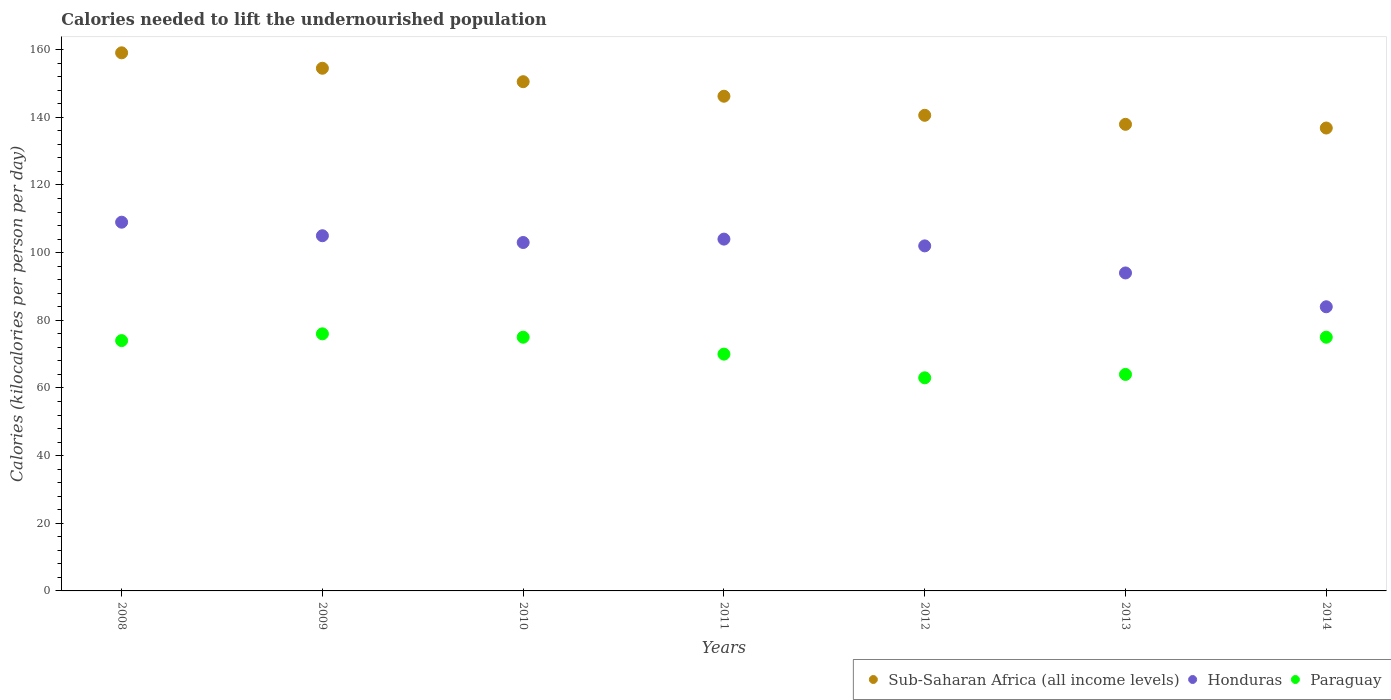How many different coloured dotlines are there?
Provide a short and direct response. 3. Is the number of dotlines equal to the number of legend labels?
Your response must be concise. Yes. What is the total calories needed to lift the undernourished population in Honduras in 2009?
Your response must be concise. 105. Across all years, what is the maximum total calories needed to lift the undernourished population in Sub-Saharan Africa (all income levels)?
Provide a succinct answer. 159.07. Across all years, what is the minimum total calories needed to lift the undernourished population in Paraguay?
Ensure brevity in your answer.  63. In which year was the total calories needed to lift the undernourished population in Paraguay maximum?
Your response must be concise. 2009. In which year was the total calories needed to lift the undernourished population in Honduras minimum?
Ensure brevity in your answer.  2014. What is the total total calories needed to lift the undernourished population in Paraguay in the graph?
Ensure brevity in your answer.  497. What is the difference between the total calories needed to lift the undernourished population in Sub-Saharan Africa (all income levels) in 2009 and that in 2010?
Give a very brief answer. 3.97. What is the difference between the total calories needed to lift the undernourished population in Paraguay in 2011 and the total calories needed to lift the undernourished population in Honduras in 2012?
Your response must be concise. -32. In the year 2013, what is the difference between the total calories needed to lift the undernourished population in Honduras and total calories needed to lift the undernourished population in Paraguay?
Provide a short and direct response. 30. What is the ratio of the total calories needed to lift the undernourished population in Paraguay in 2008 to that in 2010?
Make the answer very short. 0.99. What is the difference between the highest and the lowest total calories needed to lift the undernourished population in Sub-Saharan Africa (all income levels)?
Offer a terse response. 22.23. In how many years, is the total calories needed to lift the undernourished population in Sub-Saharan Africa (all income levels) greater than the average total calories needed to lift the undernourished population in Sub-Saharan Africa (all income levels) taken over all years?
Make the answer very short. 3. Is it the case that in every year, the sum of the total calories needed to lift the undernourished population in Honduras and total calories needed to lift the undernourished population in Paraguay  is greater than the total calories needed to lift the undernourished population in Sub-Saharan Africa (all income levels)?
Offer a terse response. Yes. Is the total calories needed to lift the undernourished population in Paraguay strictly greater than the total calories needed to lift the undernourished population in Honduras over the years?
Ensure brevity in your answer.  No. Is the total calories needed to lift the undernourished population in Honduras strictly less than the total calories needed to lift the undernourished population in Paraguay over the years?
Keep it short and to the point. No. How many years are there in the graph?
Ensure brevity in your answer.  7. What is the difference between two consecutive major ticks on the Y-axis?
Give a very brief answer. 20. Are the values on the major ticks of Y-axis written in scientific E-notation?
Your answer should be very brief. No. How many legend labels are there?
Offer a very short reply. 3. What is the title of the graph?
Ensure brevity in your answer.  Calories needed to lift the undernourished population. Does "Lebanon" appear as one of the legend labels in the graph?
Offer a terse response. No. What is the label or title of the X-axis?
Your answer should be very brief. Years. What is the label or title of the Y-axis?
Your answer should be very brief. Calories (kilocalories per person per day). What is the Calories (kilocalories per person per day) in Sub-Saharan Africa (all income levels) in 2008?
Ensure brevity in your answer.  159.07. What is the Calories (kilocalories per person per day) in Honduras in 2008?
Your response must be concise. 109. What is the Calories (kilocalories per person per day) of Sub-Saharan Africa (all income levels) in 2009?
Provide a short and direct response. 154.51. What is the Calories (kilocalories per person per day) of Honduras in 2009?
Offer a very short reply. 105. What is the Calories (kilocalories per person per day) in Paraguay in 2009?
Give a very brief answer. 76. What is the Calories (kilocalories per person per day) in Sub-Saharan Africa (all income levels) in 2010?
Provide a short and direct response. 150.54. What is the Calories (kilocalories per person per day) of Honduras in 2010?
Ensure brevity in your answer.  103. What is the Calories (kilocalories per person per day) of Paraguay in 2010?
Make the answer very short. 75. What is the Calories (kilocalories per person per day) in Sub-Saharan Africa (all income levels) in 2011?
Your answer should be very brief. 146.24. What is the Calories (kilocalories per person per day) of Honduras in 2011?
Offer a very short reply. 104. What is the Calories (kilocalories per person per day) of Sub-Saharan Africa (all income levels) in 2012?
Provide a succinct answer. 140.6. What is the Calories (kilocalories per person per day) of Honduras in 2012?
Your answer should be very brief. 102. What is the Calories (kilocalories per person per day) of Paraguay in 2012?
Your answer should be compact. 63. What is the Calories (kilocalories per person per day) in Sub-Saharan Africa (all income levels) in 2013?
Your response must be concise. 137.94. What is the Calories (kilocalories per person per day) in Honduras in 2013?
Make the answer very short. 94. What is the Calories (kilocalories per person per day) in Sub-Saharan Africa (all income levels) in 2014?
Make the answer very short. 136.84. Across all years, what is the maximum Calories (kilocalories per person per day) in Sub-Saharan Africa (all income levels)?
Make the answer very short. 159.07. Across all years, what is the maximum Calories (kilocalories per person per day) of Honduras?
Your answer should be very brief. 109. Across all years, what is the maximum Calories (kilocalories per person per day) of Paraguay?
Offer a very short reply. 76. Across all years, what is the minimum Calories (kilocalories per person per day) of Sub-Saharan Africa (all income levels)?
Your answer should be very brief. 136.84. What is the total Calories (kilocalories per person per day) in Sub-Saharan Africa (all income levels) in the graph?
Your response must be concise. 1025.74. What is the total Calories (kilocalories per person per day) of Honduras in the graph?
Ensure brevity in your answer.  701. What is the total Calories (kilocalories per person per day) in Paraguay in the graph?
Keep it short and to the point. 497. What is the difference between the Calories (kilocalories per person per day) in Sub-Saharan Africa (all income levels) in 2008 and that in 2009?
Keep it short and to the point. 4.56. What is the difference between the Calories (kilocalories per person per day) in Honduras in 2008 and that in 2009?
Offer a terse response. 4. What is the difference between the Calories (kilocalories per person per day) of Paraguay in 2008 and that in 2009?
Give a very brief answer. -2. What is the difference between the Calories (kilocalories per person per day) in Sub-Saharan Africa (all income levels) in 2008 and that in 2010?
Keep it short and to the point. 8.54. What is the difference between the Calories (kilocalories per person per day) of Honduras in 2008 and that in 2010?
Your answer should be very brief. 6. What is the difference between the Calories (kilocalories per person per day) of Paraguay in 2008 and that in 2010?
Keep it short and to the point. -1. What is the difference between the Calories (kilocalories per person per day) of Sub-Saharan Africa (all income levels) in 2008 and that in 2011?
Make the answer very short. 12.83. What is the difference between the Calories (kilocalories per person per day) in Honduras in 2008 and that in 2011?
Your response must be concise. 5. What is the difference between the Calories (kilocalories per person per day) of Paraguay in 2008 and that in 2011?
Make the answer very short. 4. What is the difference between the Calories (kilocalories per person per day) of Sub-Saharan Africa (all income levels) in 2008 and that in 2012?
Give a very brief answer. 18.47. What is the difference between the Calories (kilocalories per person per day) of Honduras in 2008 and that in 2012?
Provide a short and direct response. 7. What is the difference between the Calories (kilocalories per person per day) of Paraguay in 2008 and that in 2012?
Make the answer very short. 11. What is the difference between the Calories (kilocalories per person per day) of Sub-Saharan Africa (all income levels) in 2008 and that in 2013?
Offer a very short reply. 21.14. What is the difference between the Calories (kilocalories per person per day) in Honduras in 2008 and that in 2013?
Offer a terse response. 15. What is the difference between the Calories (kilocalories per person per day) of Paraguay in 2008 and that in 2013?
Your answer should be compact. 10. What is the difference between the Calories (kilocalories per person per day) of Sub-Saharan Africa (all income levels) in 2008 and that in 2014?
Make the answer very short. 22.23. What is the difference between the Calories (kilocalories per person per day) in Honduras in 2008 and that in 2014?
Offer a very short reply. 25. What is the difference between the Calories (kilocalories per person per day) in Sub-Saharan Africa (all income levels) in 2009 and that in 2010?
Ensure brevity in your answer.  3.97. What is the difference between the Calories (kilocalories per person per day) of Paraguay in 2009 and that in 2010?
Ensure brevity in your answer.  1. What is the difference between the Calories (kilocalories per person per day) of Sub-Saharan Africa (all income levels) in 2009 and that in 2011?
Offer a terse response. 8.27. What is the difference between the Calories (kilocalories per person per day) in Sub-Saharan Africa (all income levels) in 2009 and that in 2012?
Ensure brevity in your answer.  13.91. What is the difference between the Calories (kilocalories per person per day) of Paraguay in 2009 and that in 2012?
Provide a succinct answer. 13. What is the difference between the Calories (kilocalories per person per day) in Sub-Saharan Africa (all income levels) in 2009 and that in 2013?
Make the answer very short. 16.58. What is the difference between the Calories (kilocalories per person per day) of Honduras in 2009 and that in 2013?
Your answer should be compact. 11. What is the difference between the Calories (kilocalories per person per day) of Paraguay in 2009 and that in 2013?
Your response must be concise. 12. What is the difference between the Calories (kilocalories per person per day) in Sub-Saharan Africa (all income levels) in 2009 and that in 2014?
Ensure brevity in your answer.  17.67. What is the difference between the Calories (kilocalories per person per day) of Sub-Saharan Africa (all income levels) in 2010 and that in 2011?
Give a very brief answer. 4.3. What is the difference between the Calories (kilocalories per person per day) of Sub-Saharan Africa (all income levels) in 2010 and that in 2012?
Your answer should be very brief. 9.93. What is the difference between the Calories (kilocalories per person per day) in Honduras in 2010 and that in 2012?
Make the answer very short. 1. What is the difference between the Calories (kilocalories per person per day) of Sub-Saharan Africa (all income levels) in 2010 and that in 2013?
Provide a succinct answer. 12.6. What is the difference between the Calories (kilocalories per person per day) in Paraguay in 2010 and that in 2013?
Make the answer very short. 11. What is the difference between the Calories (kilocalories per person per day) of Sub-Saharan Africa (all income levels) in 2010 and that in 2014?
Your answer should be compact. 13.7. What is the difference between the Calories (kilocalories per person per day) of Honduras in 2010 and that in 2014?
Offer a terse response. 19. What is the difference between the Calories (kilocalories per person per day) of Paraguay in 2010 and that in 2014?
Your answer should be very brief. 0. What is the difference between the Calories (kilocalories per person per day) of Sub-Saharan Africa (all income levels) in 2011 and that in 2012?
Offer a very short reply. 5.64. What is the difference between the Calories (kilocalories per person per day) in Sub-Saharan Africa (all income levels) in 2011 and that in 2013?
Give a very brief answer. 8.31. What is the difference between the Calories (kilocalories per person per day) in Honduras in 2011 and that in 2013?
Your response must be concise. 10. What is the difference between the Calories (kilocalories per person per day) in Sub-Saharan Africa (all income levels) in 2011 and that in 2014?
Offer a terse response. 9.4. What is the difference between the Calories (kilocalories per person per day) of Sub-Saharan Africa (all income levels) in 2012 and that in 2013?
Offer a terse response. 2.67. What is the difference between the Calories (kilocalories per person per day) of Honduras in 2012 and that in 2013?
Give a very brief answer. 8. What is the difference between the Calories (kilocalories per person per day) of Paraguay in 2012 and that in 2013?
Offer a terse response. -1. What is the difference between the Calories (kilocalories per person per day) of Sub-Saharan Africa (all income levels) in 2012 and that in 2014?
Your answer should be very brief. 3.76. What is the difference between the Calories (kilocalories per person per day) of Sub-Saharan Africa (all income levels) in 2013 and that in 2014?
Your response must be concise. 1.1. What is the difference between the Calories (kilocalories per person per day) in Paraguay in 2013 and that in 2014?
Provide a succinct answer. -11. What is the difference between the Calories (kilocalories per person per day) in Sub-Saharan Africa (all income levels) in 2008 and the Calories (kilocalories per person per day) in Honduras in 2009?
Offer a very short reply. 54.07. What is the difference between the Calories (kilocalories per person per day) of Sub-Saharan Africa (all income levels) in 2008 and the Calories (kilocalories per person per day) of Paraguay in 2009?
Your answer should be very brief. 83.07. What is the difference between the Calories (kilocalories per person per day) of Honduras in 2008 and the Calories (kilocalories per person per day) of Paraguay in 2009?
Provide a succinct answer. 33. What is the difference between the Calories (kilocalories per person per day) in Sub-Saharan Africa (all income levels) in 2008 and the Calories (kilocalories per person per day) in Honduras in 2010?
Keep it short and to the point. 56.07. What is the difference between the Calories (kilocalories per person per day) of Sub-Saharan Africa (all income levels) in 2008 and the Calories (kilocalories per person per day) of Paraguay in 2010?
Provide a succinct answer. 84.07. What is the difference between the Calories (kilocalories per person per day) in Honduras in 2008 and the Calories (kilocalories per person per day) in Paraguay in 2010?
Offer a very short reply. 34. What is the difference between the Calories (kilocalories per person per day) in Sub-Saharan Africa (all income levels) in 2008 and the Calories (kilocalories per person per day) in Honduras in 2011?
Give a very brief answer. 55.07. What is the difference between the Calories (kilocalories per person per day) in Sub-Saharan Africa (all income levels) in 2008 and the Calories (kilocalories per person per day) in Paraguay in 2011?
Offer a very short reply. 89.07. What is the difference between the Calories (kilocalories per person per day) of Sub-Saharan Africa (all income levels) in 2008 and the Calories (kilocalories per person per day) of Honduras in 2012?
Offer a terse response. 57.07. What is the difference between the Calories (kilocalories per person per day) of Sub-Saharan Africa (all income levels) in 2008 and the Calories (kilocalories per person per day) of Paraguay in 2012?
Keep it short and to the point. 96.07. What is the difference between the Calories (kilocalories per person per day) in Honduras in 2008 and the Calories (kilocalories per person per day) in Paraguay in 2012?
Your answer should be compact. 46. What is the difference between the Calories (kilocalories per person per day) of Sub-Saharan Africa (all income levels) in 2008 and the Calories (kilocalories per person per day) of Honduras in 2013?
Keep it short and to the point. 65.07. What is the difference between the Calories (kilocalories per person per day) in Sub-Saharan Africa (all income levels) in 2008 and the Calories (kilocalories per person per day) in Paraguay in 2013?
Provide a short and direct response. 95.07. What is the difference between the Calories (kilocalories per person per day) in Honduras in 2008 and the Calories (kilocalories per person per day) in Paraguay in 2013?
Your answer should be compact. 45. What is the difference between the Calories (kilocalories per person per day) in Sub-Saharan Africa (all income levels) in 2008 and the Calories (kilocalories per person per day) in Honduras in 2014?
Keep it short and to the point. 75.07. What is the difference between the Calories (kilocalories per person per day) in Sub-Saharan Africa (all income levels) in 2008 and the Calories (kilocalories per person per day) in Paraguay in 2014?
Provide a short and direct response. 84.07. What is the difference between the Calories (kilocalories per person per day) in Sub-Saharan Africa (all income levels) in 2009 and the Calories (kilocalories per person per day) in Honduras in 2010?
Give a very brief answer. 51.51. What is the difference between the Calories (kilocalories per person per day) of Sub-Saharan Africa (all income levels) in 2009 and the Calories (kilocalories per person per day) of Paraguay in 2010?
Give a very brief answer. 79.51. What is the difference between the Calories (kilocalories per person per day) of Honduras in 2009 and the Calories (kilocalories per person per day) of Paraguay in 2010?
Provide a succinct answer. 30. What is the difference between the Calories (kilocalories per person per day) in Sub-Saharan Africa (all income levels) in 2009 and the Calories (kilocalories per person per day) in Honduras in 2011?
Your answer should be compact. 50.51. What is the difference between the Calories (kilocalories per person per day) in Sub-Saharan Africa (all income levels) in 2009 and the Calories (kilocalories per person per day) in Paraguay in 2011?
Keep it short and to the point. 84.51. What is the difference between the Calories (kilocalories per person per day) in Honduras in 2009 and the Calories (kilocalories per person per day) in Paraguay in 2011?
Your answer should be compact. 35. What is the difference between the Calories (kilocalories per person per day) in Sub-Saharan Africa (all income levels) in 2009 and the Calories (kilocalories per person per day) in Honduras in 2012?
Offer a terse response. 52.51. What is the difference between the Calories (kilocalories per person per day) in Sub-Saharan Africa (all income levels) in 2009 and the Calories (kilocalories per person per day) in Paraguay in 2012?
Provide a succinct answer. 91.51. What is the difference between the Calories (kilocalories per person per day) in Sub-Saharan Africa (all income levels) in 2009 and the Calories (kilocalories per person per day) in Honduras in 2013?
Your answer should be compact. 60.51. What is the difference between the Calories (kilocalories per person per day) of Sub-Saharan Africa (all income levels) in 2009 and the Calories (kilocalories per person per day) of Paraguay in 2013?
Provide a succinct answer. 90.51. What is the difference between the Calories (kilocalories per person per day) in Sub-Saharan Africa (all income levels) in 2009 and the Calories (kilocalories per person per day) in Honduras in 2014?
Provide a short and direct response. 70.51. What is the difference between the Calories (kilocalories per person per day) of Sub-Saharan Africa (all income levels) in 2009 and the Calories (kilocalories per person per day) of Paraguay in 2014?
Your response must be concise. 79.51. What is the difference between the Calories (kilocalories per person per day) in Honduras in 2009 and the Calories (kilocalories per person per day) in Paraguay in 2014?
Provide a short and direct response. 30. What is the difference between the Calories (kilocalories per person per day) of Sub-Saharan Africa (all income levels) in 2010 and the Calories (kilocalories per person per day) of Honduras in 2011?
Offer a very short reply. 46.54. What is the difference between the Calories (kilocalories per person per day) in Sub-Saharan Africa (all income levels) in 2010 and the Calories (kilocalories per person per day) in Paraguay in 2011?
Offer a very short reply. 80.54. What is the difference between the Calories (kilocalories per person per day) in Sub-Saharan Africa (all income levels) in 2010 and the Calories (kilocalories per person per day) in Honduras in 2012?
Keep it short and to the point. 48.54. What is the difference between the Calories (kilocalories per person per day) in Sub-Saharan Africa (all income levels) in 2010 and the Calories (kilocalories per person per day) in Paraguay in 2012?
Keep it short and to the point. 87.54. What is the difference between the Calories (kilocalories per person per day) in Sub-Saharan Africa (all income levels) in 2010 and the Calories (kilocalories per person per day) in Honduras in 2013?
Keep it short and to the point. 56.54. What is the difference between the Calories (kilocalories per person per day) of Sub-Saharan Africa (all income levels) in 2010 and the Calories (kilocalories per person per day) of Paraguay in 2013?
Offer a terse response. 86.54. What is the difference between the Calories (kilocalories per person per day) in Sub-Saharan Africa (all income levels) in 2010 and the Calories (kilocalories per person per day) in Honduras in 2014?
Offer a terse response. 66.54. What is the difference between the Calories (kilocalories per person per day) in Sub-Saharan Africa (all income levels) in 2010 and the Calories (kilocalories per person per day) in Paraguay in 2014?
Make the answer very short. 75.54. What is the difference between the Calories (kilocalories per person per day) in Honduras in 2010 and the Calories (kilocalories per person per day) in Paraguay in 2014?
Offer a terse response. 28. What is the difference between the Calories (kilocalories per person per day) in Sub-Saharan Africa (all income levels) in 2011 and the Calories (kilocalories per person per day) in Honduras in 2012?
Ensure brevity in your answer.  44.24. What is the difference between the Calories (kilocalories per person per day) in Sub-Saharan Africa (all income levels) in 2011 and the Calories (kilocalories per person per day) in Paraguay in 2012?
Give a very brief answer. 83.24. What is the difference between the Calories (kilocalories per person per day) in Sub-Saharan Africa (all income levels) in 2011 and the Calories (kilocalories per person per day) in Honduras in 2013?
Your answer should be very brief. 52.24. What is the difference between the Calories (kilocalories per person per day) in Sub-Saharan Africa (all income levels) in 2011 and the Calories (kilocalories per person per day) in Paraguay in 2013?
Offer a terse response. 82.24. What is the difference between the Calories (kilocalories per person per day) of Sub-Saharan Africa (all income levels) in 2011 and the Calories (kilocalories per person per day) of Honduras in 2014?
Give a very brief answer. 62.24. What is the difference between the Calories (kilocalories per person per day) of Sub-Saharan Africa (all income levels) in 2011 and the Calories (kilocalories per person per day) of Paraguay in 2014?
Give a very brief answer. 71.24. What is the difference between the Calories (kilocalories per person per day) of Honduras in 2011 and the Calories (kilocalories per person per day) of Paraguay in 2014?
Make the answer very short. 29. What is the difference between the Calories (kilocalories per person per day) in Sub-Saharan Africa (all income levels) in 2012 and the Calories (kilocalories per person per day) in Honduras in 2013?
Ensure brevity in your answer.  46.6. What is the difference between the Calories (kilocalories per person per day) of Sub-Saharan Africa (all income levels) in 2012 and the Calories (kilocalories per person per day) of Paraguay in 2013?
Provide a short and direct response. 76.6. What is the difference between the Calories (kilocalories per person per day) in Sub-Saharan Africa (all income levels) in 2012 and the Calories (kilocalories per person per day) in Honduras in 2014?
Ensure brevity in your answer.  56.6. What is the difference between the Calories (kilocalories per person per day) in Sub-Saharan Africa (all income levels) in 2012 and the Calories (kilocalories per person per day) in Paraguay in 2014?
Make the answer very short. 65.6. What is the difference between the Calories (kilocalories per person per day) of Honduras in 2012 and the Calories (kilocalories per person per day) of Paraguay in 2014?
Provide a short and direct response. 27. What is the difference between the Calories (kilocalories per person per day) in Sub-Saharan Africa (all income levels) in 2013 and the Calories (kilocalories per person per day) in Honduras in 2014?
Your answer should be very brief. 53.94. What is the difference between the Calories (kilocalories per person per day) of Sub-Saharan Africa (all income levels) in 2013 and the Calories (kilocalories per person per day) of Paraguay in 2014?
Provide a succinct answer. 62.94. What is the difference between the Calories (kilocalories per person per day) in Honduras in 2013 and the Calories (kilocalories per person per day) in Paraguay in 2014?
Keep it short and to the point. 19. What is the average Calories (kilocalories per person per day) in Sub-Saharan Africa (all income levels) per year?
Your response must be concise. 146.53. What is the average Calories (kilocalories per person per day) in Honduras per year?
Ensure brevity in your answer.  100.14. In the year 2008, what is the difference between the Calories (kilocalories per person per day) of Sub-Saharan Africa (all income levels) and Calories (kilocalories per person per day) of Honduras?
Your answer should be compact. 50.07. In the year 2008, what is the difference between the Calories (kilocalories per person per day) in Sub-Saharan Africa (all income levels) and Calories (kilocalories per person per day) in Paraguay?
Your answer should be very brief. 85.07. In the year 2008, what is the difference between the Calories (kilocalories per person per day) of Honduras and Calories (kilocalories per person per day) of Paraguay?
Your answer should be compact. 35. In the year 2009, what is the difference between the Calories (kilocalories per person per day) in Sub-Saharan Africa (all income levels) and Calories (kilocalories per person per day) in Honduras?
Your answer should be very brief. 49.51. In the year 2009, what is the difference between the Calories (kilocalories per person per day) in Sub-Saharan Africa (all income levels) and Calories (kilocalories per person per day) in Paraguay?
Provide a short and direct response. 78.51. In the year 2009, what is the difference between the Calories (kilocalories per person per day) of Honduras and Calories (kilocalories per person per day) of Paraguay?
Your response must be concise. 29. In the year 2010, what is the difference between the Calories (kilocalories per person per day) in Sub-Saharan Africa (all income levels) and Calories (kilocalories per person per day) in Honduras?
Your answer should be very brief. 47.54. In the year 2010, what is the difference between the Calories (kilocalories per person per day) in Sub-Saharan Africa (all income levels) and Calories (kilocalories per person per day) in Paraguay?
Provide a short and direct response. 75.54. In the year 2011, what is the difference between the Calories (kilocalories per person per day) in Sub-Saharan Africa (all income levels) and Calories (kilocalories per person per day) in Honduras?
Keep it short and to the point. 42.24. In the year 2011, what is the difference between the Calories (kilocalories per person per day) in Sub-Saharan Africa (all income levels) and Calories (kilocalories per person per day) in Paraguay?
Give a very brief answer. 76.24. In the year 2011, what is the difference between the Calories (kilocalories per person per day) of Honduras and Calories (kilocalories per person per day) of Paraguay?
Give a very brief answer. 34. In the year 2012, what is the difference between the Calories (kilocalories per person per day) of Sub-Saharan Africa (all income levels) and Calories (kilocalories per person per day) of Honduras?
Offer a very short reply. 38.6. In the year 2012, what is the difference between the Calories (kilocalories per person per day) in Sub-Saharan Africa (all income levels) and Calories (kilocalories per person per day) in Paraguay?
Provide a succinct answer. 77.6. In the year 2013, what is the difference between the Calories (kilocalories per person per day) in Sub-Saharan Africa (all income levels) and Calories (kilocalories per person per day) in Honduras?
Ensure brevity in your answer.  43.94. In the year 2013, what is the difference between the Calories (kilocalories per person per day) of Sub-Saharan Africa (all income levels) and Calories (kilocalories per person per day) of Paraguay?
Keep it short and to the point. 73.94. In the year 2013, what is the difference between the Calories (kilocalories per person per day) in Honduras and Calories (kilocalories per person per day) in Paraguay?
Offer a very short reply. 30. In the year 2014, what is the difference between the Calories (kilocalories per person per day) in Sub-Saharan Africa (all income levels) and Calories (kilocalories per person per day) in Honduras?
Provide a short and direct response. 52.84. In the year 2014, what is the difference between the Calories (kilocalories per person per day) of Sub-Saharan Africa (all income levels) and Calories (kilocalories per person per day) of Paraguay?
Ensure brevity in your answer.  61.84. In the year 2014, what is the difference between the Calories (kilocalories per person per day) of Honduras and Calories (kilocalories per person per day) of Paraguay?
Provide a succinct answer. 9. What is the ratio of the Calories (kilocalories per person per day) of Sub-Saharan Africa (all income levels) in 2008 to that in 2009?
Provide a succinct answer. 1.03. What is the ratio of the Calories (kilocalories per person per day) in Honduras in 2008 to that in 2009?
Offer a very short reply. 1.04. What is the ratio of the Calories (kilocalories per person per day) of Paraguay in 2008 to that in 2009?
Keep it short and to the point. 0.97. What is the ratio of the Calories (kilocalories per person per day) in Sub-Saharan Africa (all income levels) in 2008 to that in 2010?
Give a very brief answer. 1.06. What is the ratio of the Calories (kilocalories per person per day) in Honduras in 2008 to that in 2010?
Ensure brevity in your answer.  1.06. What is the ratio of the Calories (kilocalories per person per day) of Paraguay in 2008 to that in 2010?
Provide a short and direct response. 0.99. What is the ratio of the Calories (kilocalories per person per day) in Sub-Saharan Africa (all income levels) in 2008 to that in 2011?
Provide a succinct answer. 1.09. What is the ratio of the Calories (kilocalories per person per day) of Honduras in 2008 to that in 2011?
Your response must be concise. 1.05. What is the ratio of the Calories (kilocalories per person per day) of Paraguay in 2008 to that in 2011?
Your answer should be compact. 1.06. What is the ratio of the Calories (kilocalories per person per day) of Sub-Saharan Africa (all income levels) in 2008 to that in 2012?
Provide a succinct answer. 1.13. What is the ratio of the Calories (kilocalories per person per day) in Honduras in 2008 to that in 2012?
Give a very brief answer. 1.07. What is the ratio of the Calories (kilocalories per person per day) of Paraguay in 2008 to that in 2012?
Give a very brief answer. 1.17. What is the ratio of the Calories (kilocalories per person per day) of Sub-Saharan Africa (all income levels) in 2008 to that in 2013?
Your response must be concise. 1.15. What is the ratio of the Calories (kilocalories per person per day) in Honduras in 2008 to that in 2013?
Ensure brevity in your answer.  1.16. What is the ratio of the Calories (kilocalories per person per day) in Paraguay in 2008 to that in 2013?
Your answer should be compact. 1.16. What is the ratio of the Calories (kilocalories per person per day) in Sub-Saharan Africa (all income levels) in 2008 to that in 2014?
Your answer should be very brief. 1.16. What is the ratio of the Calories (kilocalories per person per day) of Honduras in 2008 to that in 2014?
Your response must be concise. 1.3. What is the ratio of the Calories (kilocalories per person per day) of Paraguay in 2008 to that in 2014?
Provide a succinct answer. 0.99. What is the ratio of the Calories (kilocalories per person per day) in Sub-Saharan Africa (all income levels) in 2009 to that in 2010?
Provide a short and direct response. 1.03. What is the ratio of the Calories (kilocalories per person per day) of Honduras in 2009 to that in 2010?
Your answer should be compact. 1.02. What is the ratio of the Calories (kilocalories per person per day) of Paraguay in 2009 to that in 2010?
Offer a terse response. 1.01. What is the ratio of the Calories (kilocalories per person per day) in Sub-Saharan Africa (all income levels) in 2009 to that in 2011?
Make the answer very short. 1.06. What is the ratio of the Calories (kilocalories per person per day) in Honduras in 2009 to that in 2011?
Provide a succinct answer. 1.01. What is the ratio of the Calories (kilocalories per person per day) in Paraguay in 2009 to that in 2011?
Ensure brevity in your answer.  1.09. What is the ratio of the Calories (kilocalories per person per day) in Sub-Saharan Africa (all income levels) in 2009 to that in 2012?
Ensure brevity in your answer.  1.1. What is the ratio of the Calories (kilocalories per person per day) of Honduras in 2009 to that in 2012?
Offer a very short reply. 1.03. What is the ratio of the Calories (kilocalories per person per day) of Paraguay in 2009 to that in 2012?
Offer a very short reply. 1.21. What is the ratio of the Calories (kilocalories per person per day) of Sub-Saharan Africa (all income levels) in 2009 to that in 2013?
Offer a terse response. 1.12. What is the ratio of the Calories (kilocalories per person per day) in Honduras in 2009 to that in 2013?
Keep it short and to the point. 1.12. What is the ratio of the Calories (kilocalories per person per day) in Paraguay in 2009 to that in 2013?
Offer a very short reply. 1.19. What is the ratio of the Calories (kilocalories per person per day) of Sub-Saharan Africa (all income levels) in 2009 to that in 2014?
Provide a succinct answer. 1.13. What is the ratio of the Calories (kilocalories per person per day) of Honduras in 2009 to that in 2014?
Your response must be concise. 1.25. What is the ratio of the Calories (kilocalories per person per day) in Paraguay in 2009 to that in 2014?
Provide a short and direct response. 1.01. What is the ratio of the Calories (kilocalories per person per day) of Sub-Saharan Africa (all income levels) in 2010 to that in 2011?
Provide a succinct answer. 1.03. What is the ratio of the Calories (kilocalories per person per day) in Paraguay in 2010 to that in 2011?
Your response must be concise. 1.07. What is the ratio of the Calories (kilocalories per person per day) in Sub-Saharan Africa (all income levels) in 2010 to that in 2012?
Make the answer very short. 1.07. What is the ratio of the Calories (kilocalories per person per day) in Honduras in 2010 to that in 2012?
Offer a terse response. 1.01. What is the ratio of the Calories (kilocalories per person per day) of Paraguay in 2010 to that in 2012?
Keep it short and to the point. 1.19. What is the ratio of the Calories (kilocalories per person per day) of Sub-Saharan Africa (all income levels) in 2010 to that in 2013?
Keep it short and to the point. 1.09. What is the ratio of the Calories (kilocalories per person per day) in Honduras in 2010 to that in 2013?
Your answer should be very brief. 1.1. What is the ratio of the Calories (kilocalories per person per day) of Paraguay in 2010 to that in 2013?
Your answer should be very brief. 1.17. What is the ratio of the Calories (kilocalories per person per day) in Sub-Saharan Africa (all income levels) in 2010 to that in 2014?
Your response must be concise. 1.1. What is the ratio of the Calories (kilocalories per person per day) of Honduras in 2010 to that in 2014?
Keep it short and to the point. 1.23. What is the ratio of the Calories (kilocalories per person per day) of Paraguay in 2010 to that in 2014?
Ensure brevity in your answer.  1. What is the ratio of the Calories (kilocalories per person per day) of Sub-Saharan Africa (all income levels) in 2011 to that in 2012?
Offer a terse response. 1.04. What is the ratio of the Calories (kilocalories per person per day) in Honduras in 2011 to that in 2012?
Give a very brief answer. 1.02. What is the ratio of the Calories (kilocalories per person per day) in Sub-Saharan Africa (all income levels) in 2011 to that in 2013?
Provide a succinct answer. 1.06. What is the ratio of the Calories (kilocalories per person per day) of Honduras in 2011 to that in 2013?
Your answer should be compact. 1.11. What is the ratio of the Calories (kilocalories per person per day) of Paraguay in 2011 to that in 2013?
Offer a terse response. 1.09. What is the ratio of the Calories (kilocalories per person per day) in Sub-Saharan Africa (all income levels) in 2011 to that in 2014?
Give a very brief answer. 1.07. What is the ratio of the Calories (kilocalories per person per day) of Honduras in 2011 to that in 2014?
Offer a terse response. 1.24. What is the ratio of the Calories (kilocalories per person per day) of Paraguay in 2011 to that in 2014?
Provide a succinct answer. 0.93. What is the ratio of the Calories (kilocalories per person per day) in Sub-Saharan Africa (all income levels) in 2012 to that in 2013?
Your answer should be compact. 1.02. What is the ratio of the Calories (kilocalories per person per day) of Honduras in 2012 to that in 2013?
Offer a terse response. 1.09. What is the ratio of the Calories (kilocalories per person per day) of Paraguay in 2012 to that in 2013?
Make the answer very short. 0.98. What is the ratio of the Calories (kilocalories per person per day) in Sub-Saharan Africa (all income levels) in 2012 to that in 2014?
Give a very brief answer. 1.03. What is the ratio of the Calories (kilocalories per person per day) in Honduras in 2012 to that in 2014?
Offer a terse response. 1.21. What is the ratio of the Calories (kilocalories per person per day) in Paraguay in 2012 to that in 2014?
Make the answer very short. 0.84. What is the ratio of the Calories (kilocalories per person per day) in Honduras in 2013 to that in 2014?
Your response must be concise. 1.12. What is the ratio of the Calories (kilocalories per person per day) in Paraguay in 2013 to that in 2014?
Ensure brevity in your answer.  0.85. What is the difference between the highest and the second highest Calories (kilocalories per person per day) of Sub-Saharan Africa (all income levels)?
Offer a terse response. 4.56. What is the difference between the highest and the lowest Calories (kilocalories per person per day) of Sub-Saharan Africa (all income levels)?
Provide a short and direct response. 22.23. What is the difference between the highest and the lowest Calories (kilocalories per person per day) in Paraguay?
Offer a very short reply. 13. 